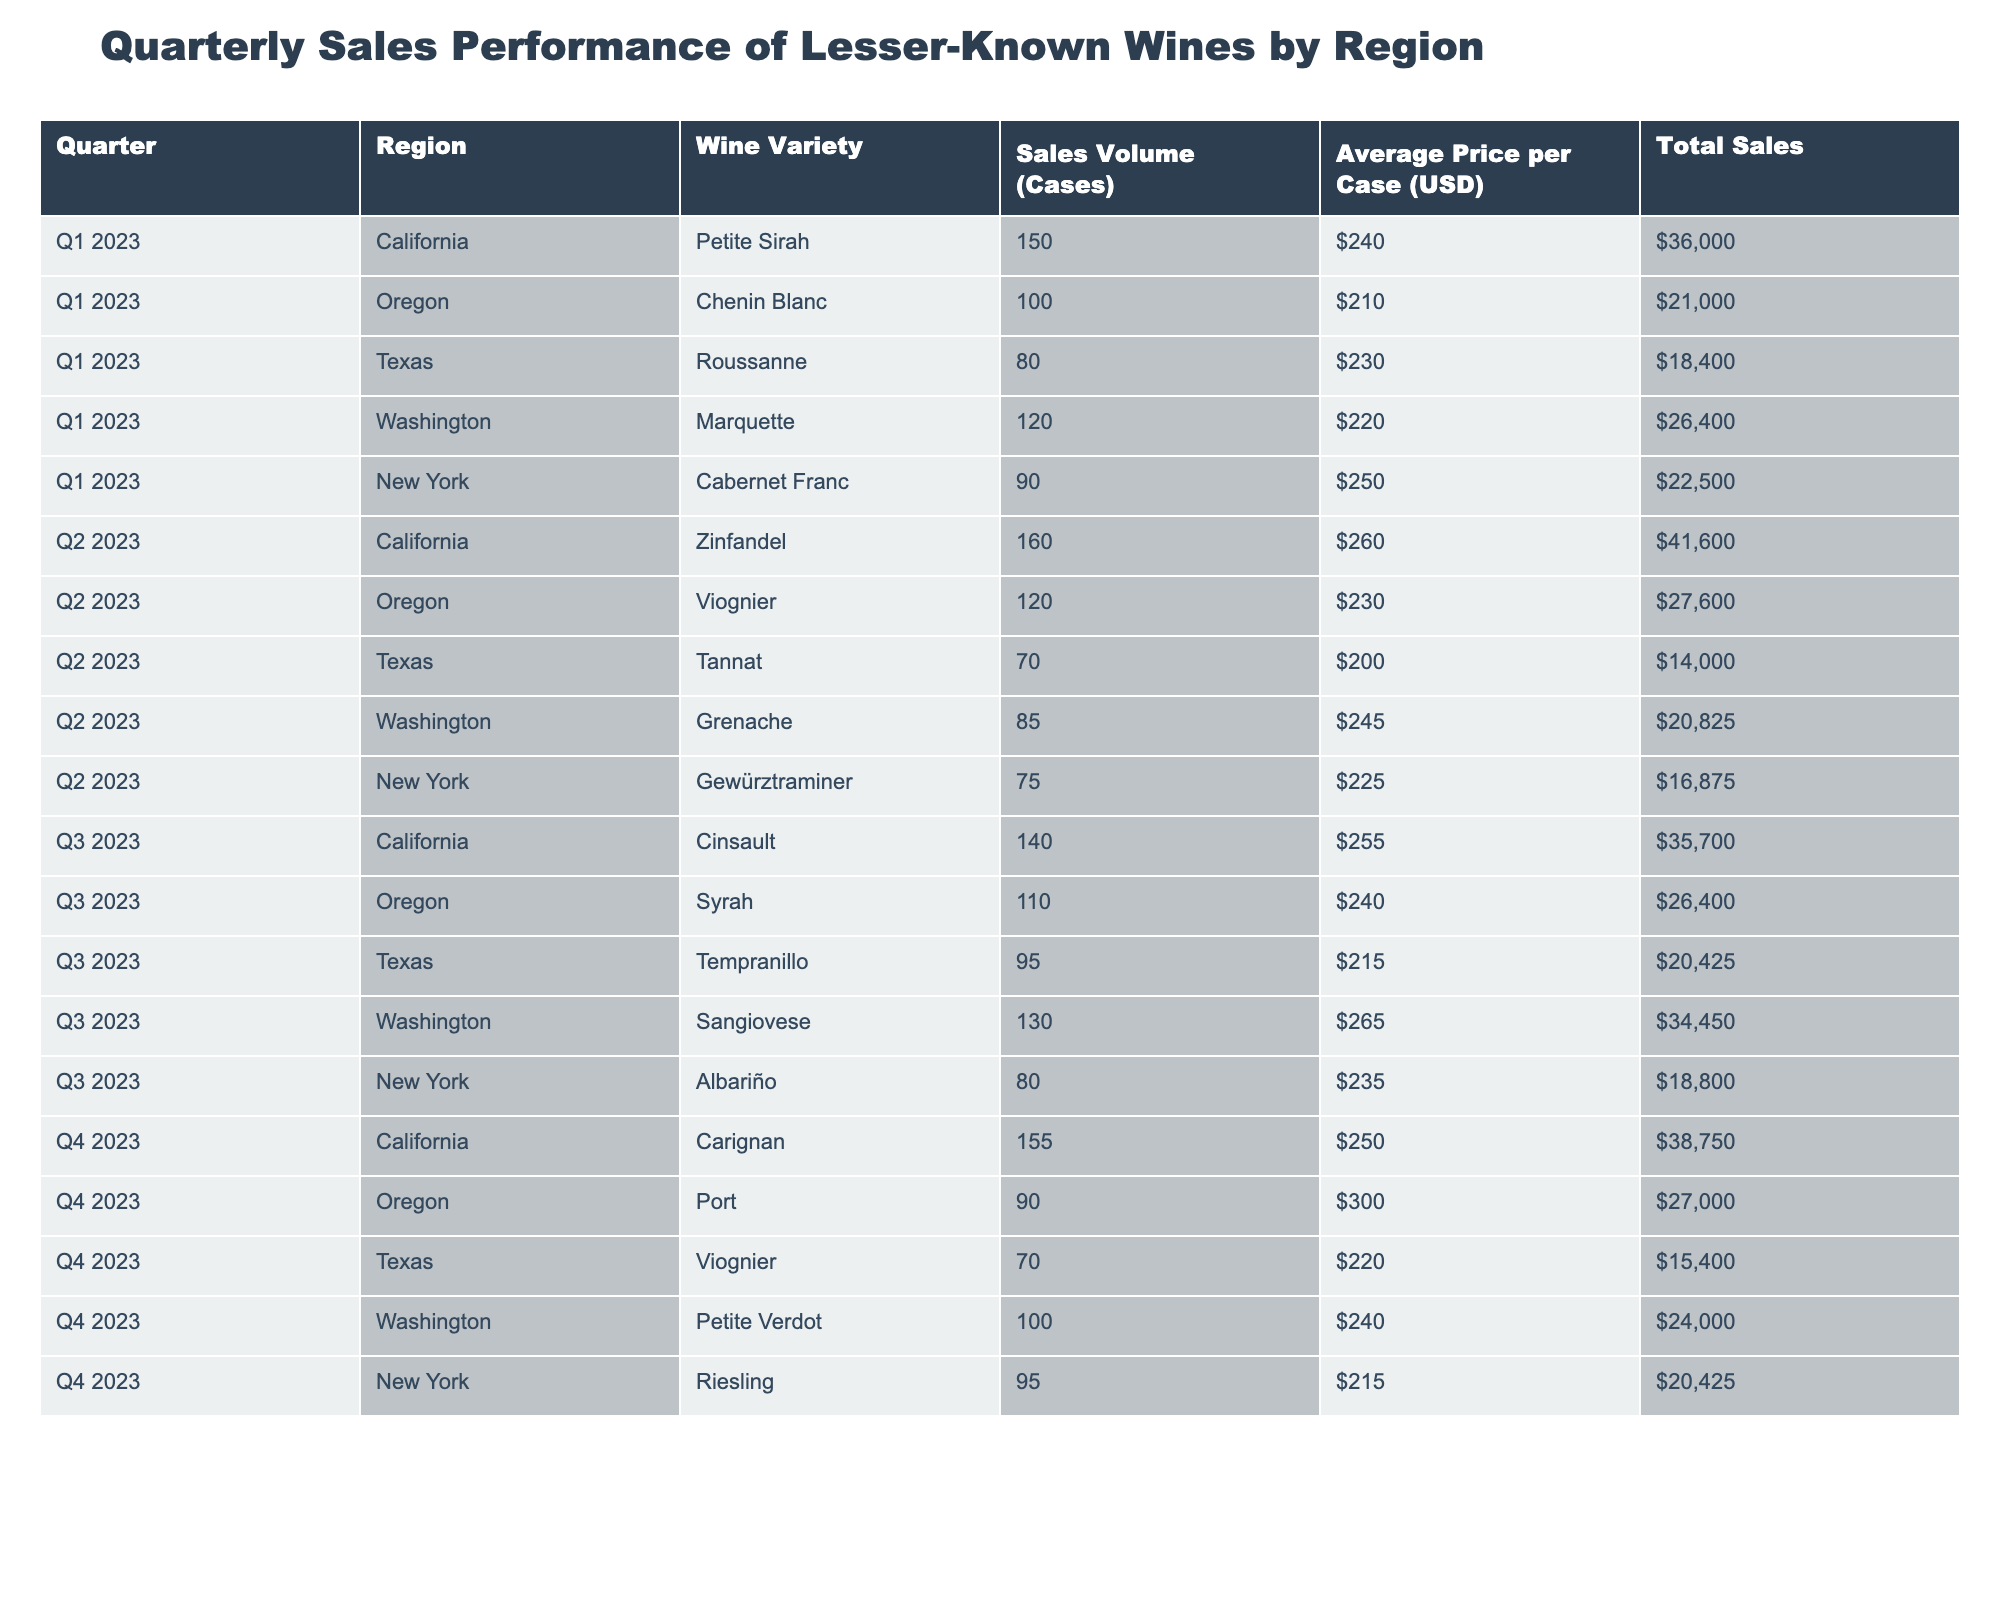What was the total sales volume for Oregon's Chenin Blanc in Q1 2023? The table shows that Oregon’s Chenin Blanc had a sales volume of 100 cases in Q1 2023.
Answer: 100 cases Which wine variety had the highest average price per case in Q3 2023? In Q3 2023, the average prices per case for the wine varieties are as follows: Cinsault ($255), Syrah ($240), Tempranillo ($215), Sangiovese ($265), and Albariño ($235). The highest price among these is Sangiovese at $265.
Answer: Sangiovese What is the total sales volume of wines from California for all quarters? The total sales volume for California is calculated by adding the sales volume for each quarter: 150 (Q1) + 160 (Q2) + 140 (Q3) + 155 (Q4) = 605 cases.
Answer: 605 cases Did Texas sell more Roussanne in Q1 2023 than Tannat in Q2 2023? Texas sold 80 cases of Roussanne in Q1 2023 and 70 cases of Tannat in Q2 2023. Since 80 is more than 70, the statement is true.
Answer: Yes What is the average sales volume for wines from New York across all quarters? The sales volumes for New York are: 90 (Q1), 75 (Q2), 80 (Q3), and 95 (Q4). To find the average, sum these values (90 + 75 + 80 + 95 = 340) and divide by the number of quarters (340 / 4 = 85).
Answer: 85 cases Which region had the highest sales volume for Petite Verdot in Q4 2023? The table indicates that only Washington sold Petite Verdot in Q4 2023, with a sales volume of 100 cases. Since there are no other entries for Petite Verdot from different regions, Washington has the highest sales volume by default.
Answer: Washington What was the difference in total sales volume between Oregon's Viognier in Q2 2023 and Texas's Tempranillo in Q3 2023? Oregon's Viognier had a sales volume of 120 cases in Q2 2023, while Texas's Tempranillo had 95 cases in Q3 2023. The difference is 120 - 95 = 25 cases.
Answer: 25 cases Which region's wine saw the lowest average price per case in Q2 2023? In Q2 2023, the average prices per case were: California Zinfandel ($260), Oregon Viognier ($230), Texas Tannat ($200), Washington Grenache ($245), and New York Gewürztraminer ($225). Texas Tannat had the lowest price at $200.
Answer: Texas 